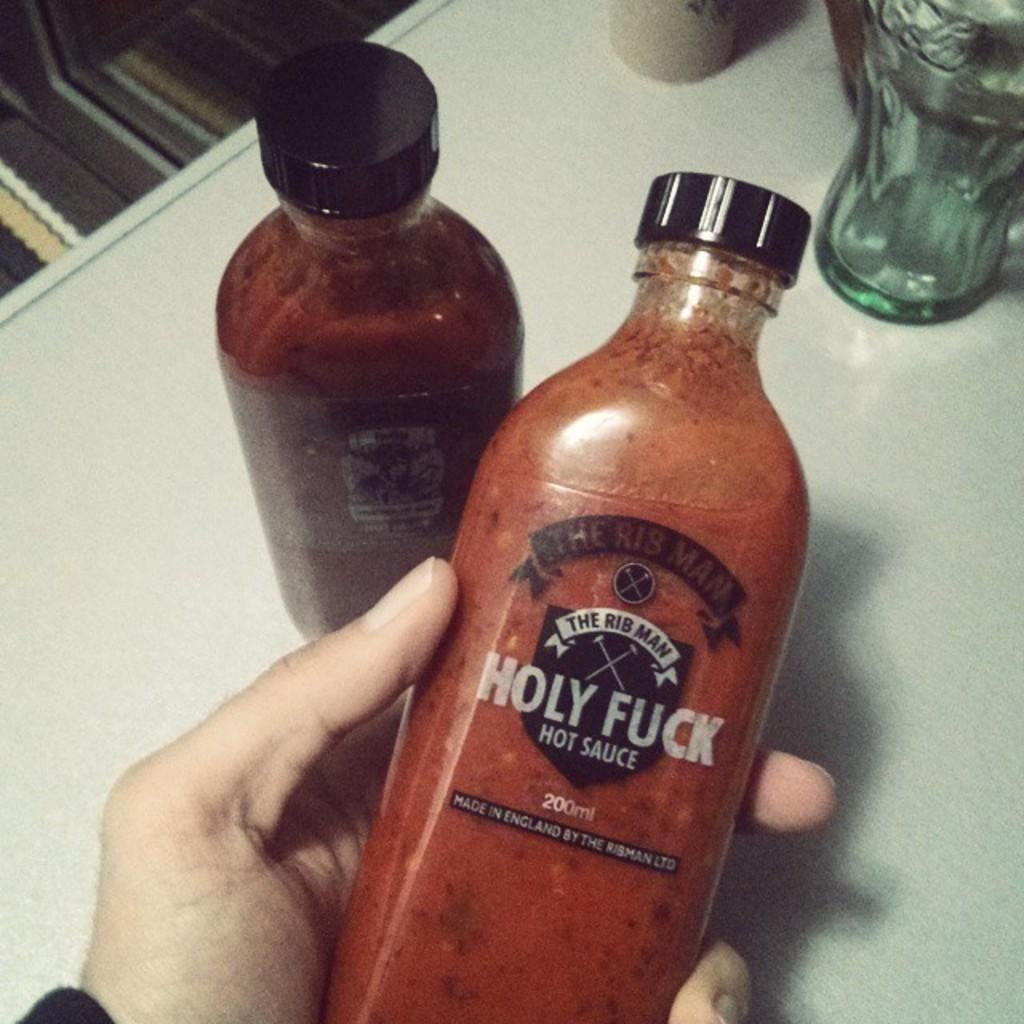What objects are visible in the image? There are bottles in the image. Where are the bottles located? The bottles are placed on a table. Is there any interaction with the bottles in the image? Yes, a person is holding a bottle. What can be said about the color of the bottle being held by the person? The bottle being held by the person is red in color. What emotion is the person holding the bottle displaying in the image? The image does not provide any information about the person's emotions, so it cannot be determined from the image. 